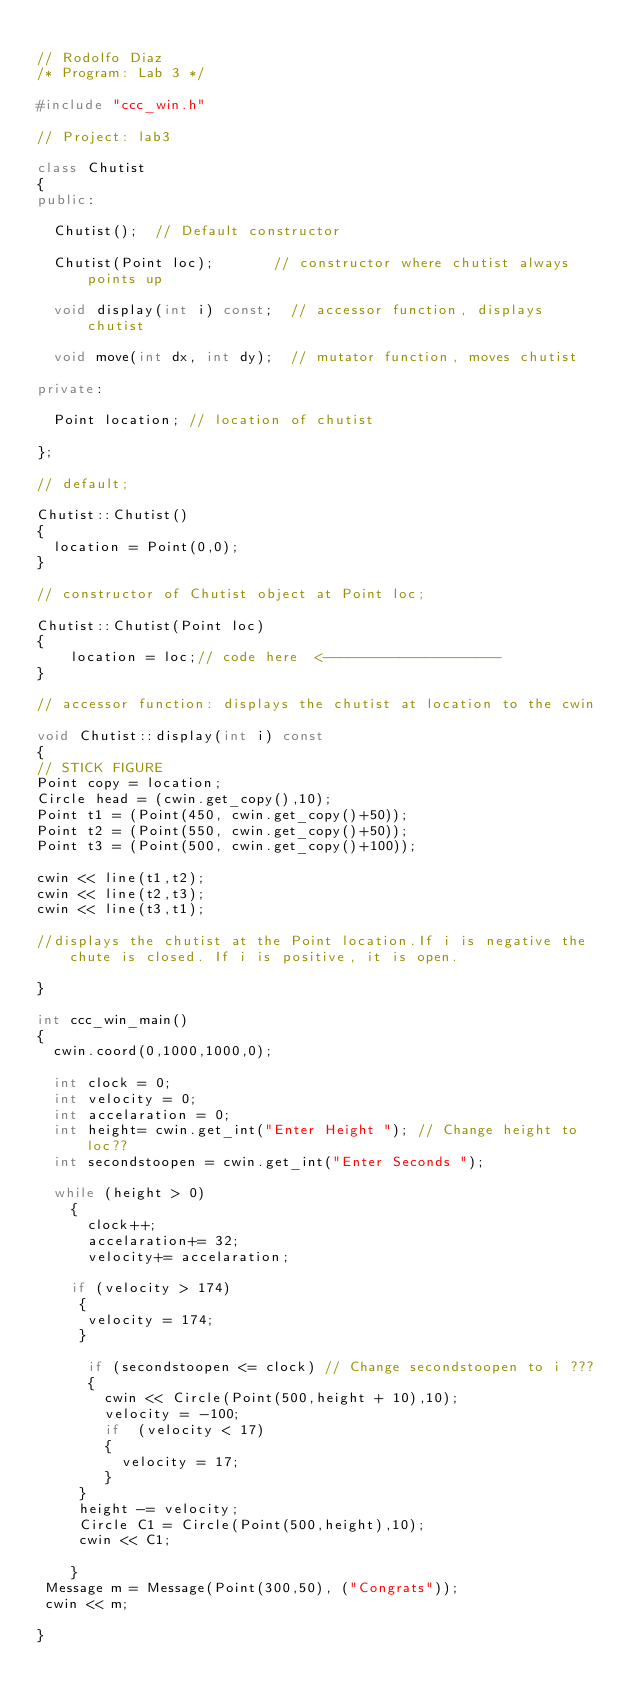<code> <loc_0><loc_0><loc_500><loc_500><_C++_>
// Rodolfo Diaz
/* Program: Lab 3 */

#include "ccc_win.h"

// Project: lab3

class Chutist
{
public:
  
  Chutist();  // Default constructor

  Chutist(Point loc);       // constructor where chutist always points up
  
  void display(int i) const;  // accessor function, displays chutist

  void move(int dx, int dy);  // mutator function, moves chutist

private:

  Point location; // location of chutist 

};

// default; 

Chutist::Chutist()
{
  location = Point(0,0);
}

// constructor of Chutist object at Point loc;

Chutist::Chutist(Point loc)
{
    location = loc;// code here  <---------------------
}

// accessor function: displays the chutist at location to the cwin

void Chutist::display(int i) const
{
// STICK FIGURE  
Point copy = location;
Circle head = (cwin.get_copy(),10);
Point t1 = (Point(450, cwin.get_copy()+50));
Point t2 = (Point(550, cwin.get_copy()+50));
Point t3 = (Point(500, cwin.get_copy()+100));

cwin << line(t1,t2);
cwin << line(t2,t3);
cwin << line(t3,t1);

//displays the chutist at the Point location.If i is negative the chute is closed. If i is positive, it is open.

}

int ccc_win_main()
{
  cwin.coord(0,1000,1000,0);

  int clock = 0; 
  int velocity = 0;
  int accelaration = 0; 
  int height= cwin.get_int("Enter Height "); // Change height to loc??
  int secondstoopen = cwin.get_int("Enter Seconds "); 
  
  while (height > 0)
    {
      clock++;
      accelaration+= 32;
      velocity+= accelaration;

    if (velocity > 174)
     {
      velocity = 174;
     }
    
      if (secondstoopen <= clock) // Change secondstoopen to i ???
      {
        cwin << Circle(Point(500,height + 10),10);
        velocity = -100;
        if  (velocity < 17)
        {
          velocity = 17;
        }
     }
     height -= velocity;
     Circle C1 = Circle(Point(500,height),10);
     cwin << C1;  
    
    }
 Message m = Message(Point(300,50), ("Congrats"));
 cwin << m;

}

</code> 